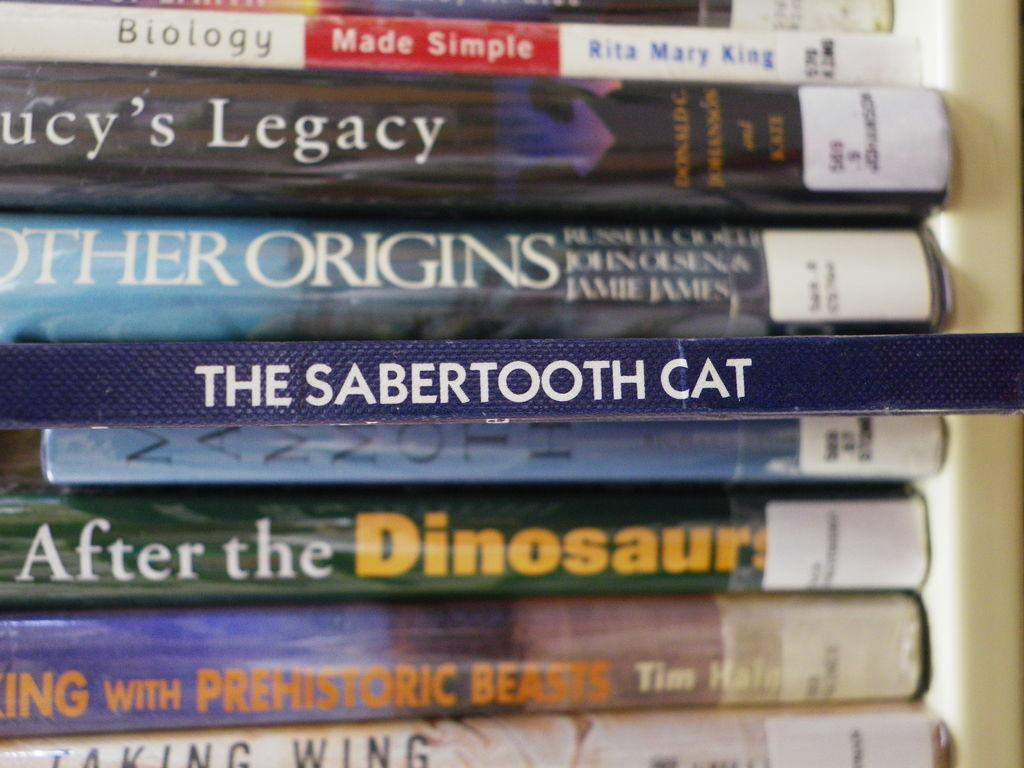Provide a one-sentence caption for the provided image. Amongst a group of books seen horizontally one titled the sabertoothcat is highlighted and stands out. 